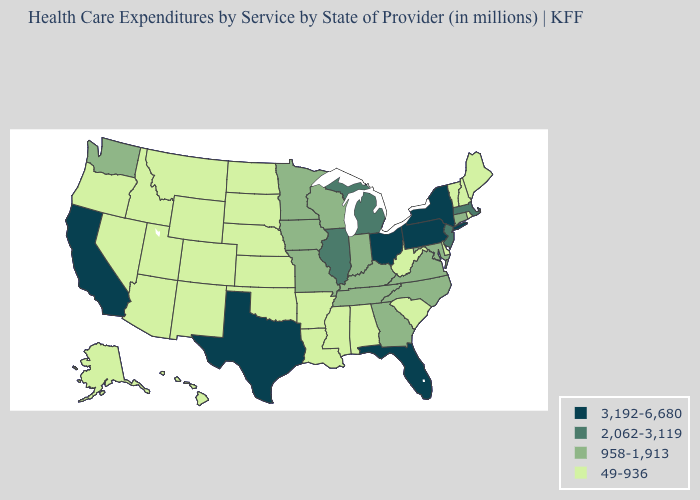Does Louisiana have the highest value in the South?
Be succinct. No. Name the states that have a value in the range 49-936?
Concise answer only. Alabama, Alaska, Arizona, Arkansas, Colorado, Delaware, Hawaii, Idaho, Kansas, Louisiana, Maine, Mississippi, Montana, Nebraska, Nevada, New Hampshire, New Mexico, North Dakota, Oklahoma, Oregon, Rhode Island, South Carolina, South Dakota, Utah, Vermont, West Virginia, Wyoming. What is the value of Kansas?
Give a very brief answer. 49-936. What is the highest value in states that border Virginia?
Write a very short answer. 958-1,913. What is the lowest value in the MidWest?
Give a very brief answer. 49-936. Is the legend a continuous bar?
Short answer required. No. What is the value of Ohio?
Concise answer only. 3,192-6,680. What is the value of Wyoming?
Concise answer only. 49-936. Name the states that have a value in the range 2,062-3,119?
Write a very short answer. Illinois, Massachusetts, Michigan, New Jersey. Does California have the lowest value in the West?
Short answer required. No. What is the value of Indiana?
Short answer required. 958-1,913. Which states hav the highest value in the MidWest?
Short answer required. Ohio. What is the lowest value in states that border New Jersey?
Answer briefly. 49-936. What is the value of North Carolina?
Keep it brief. 958-1,913. What is the highest value in the West ?
Quick response, please. 3,192-6,680. 